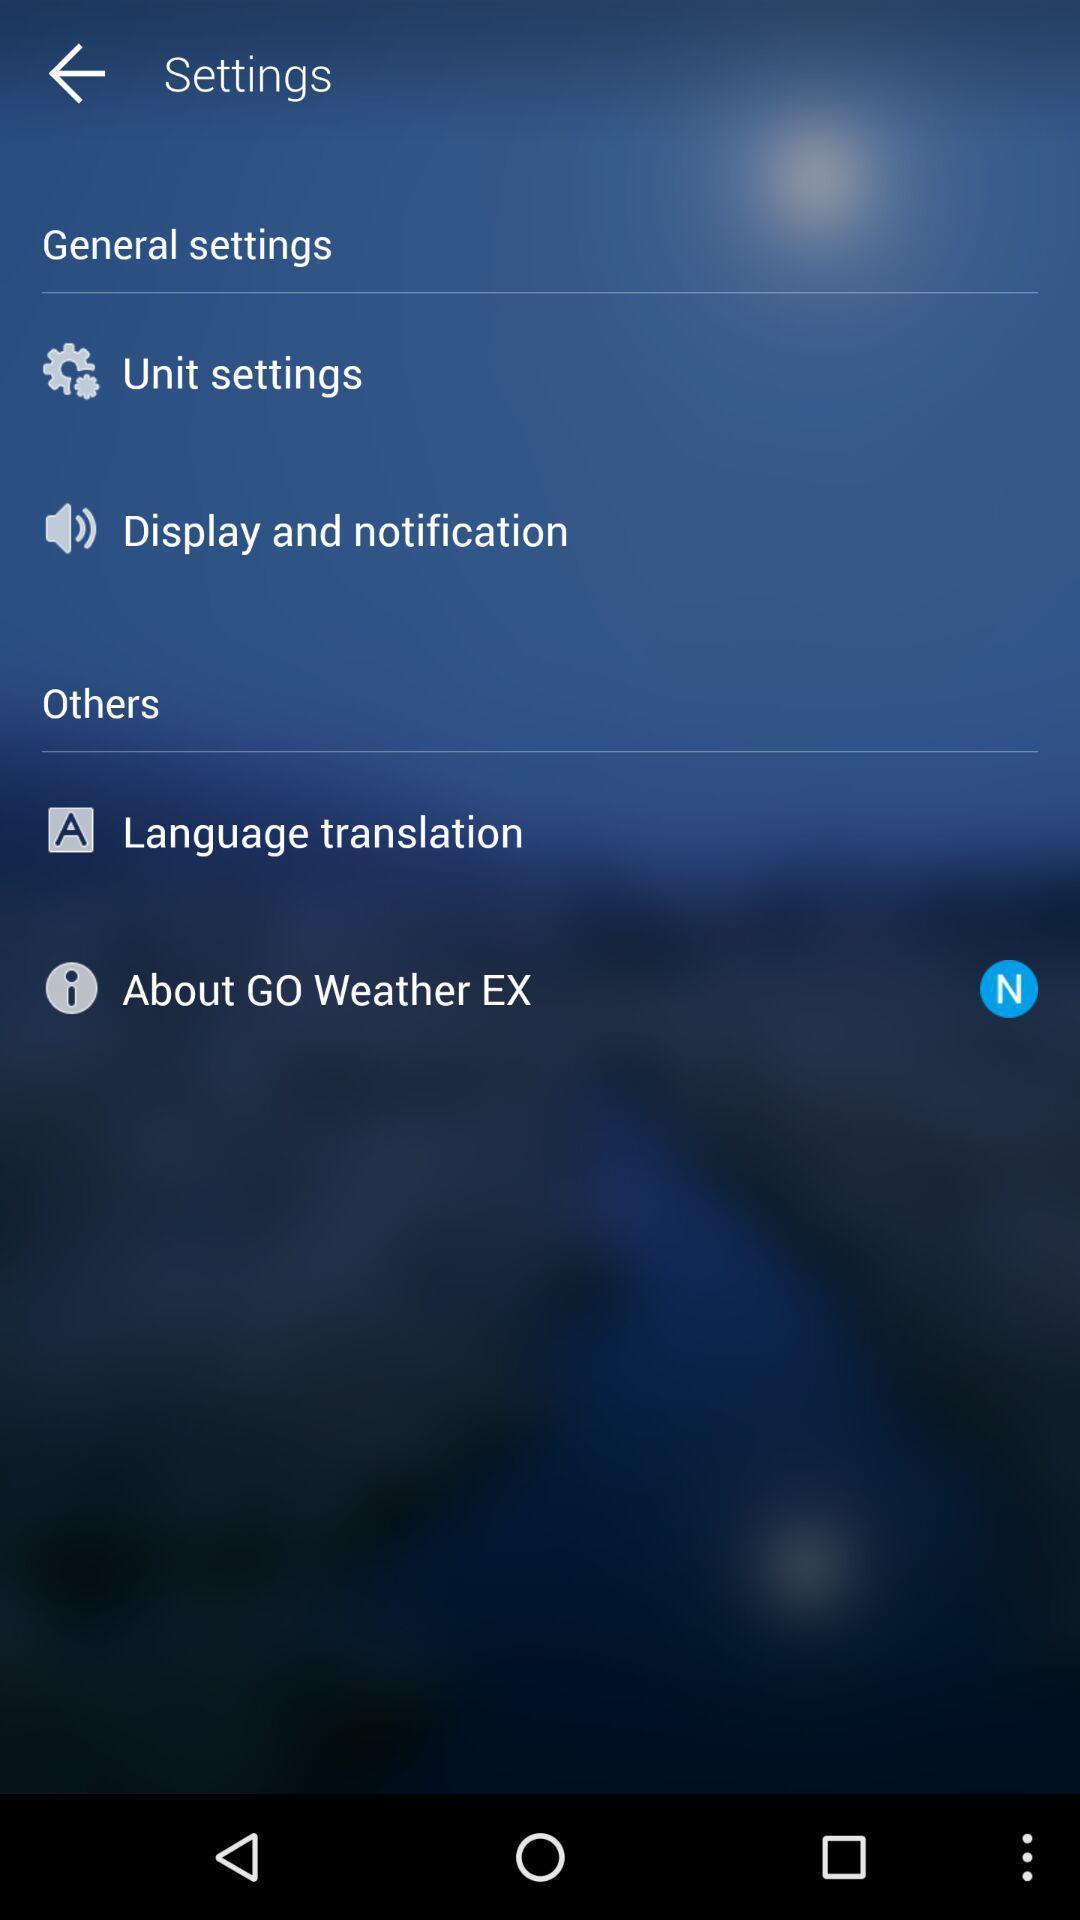Tell me about the visual elements in this screen capture. Window displaying settings page of a weather app. 